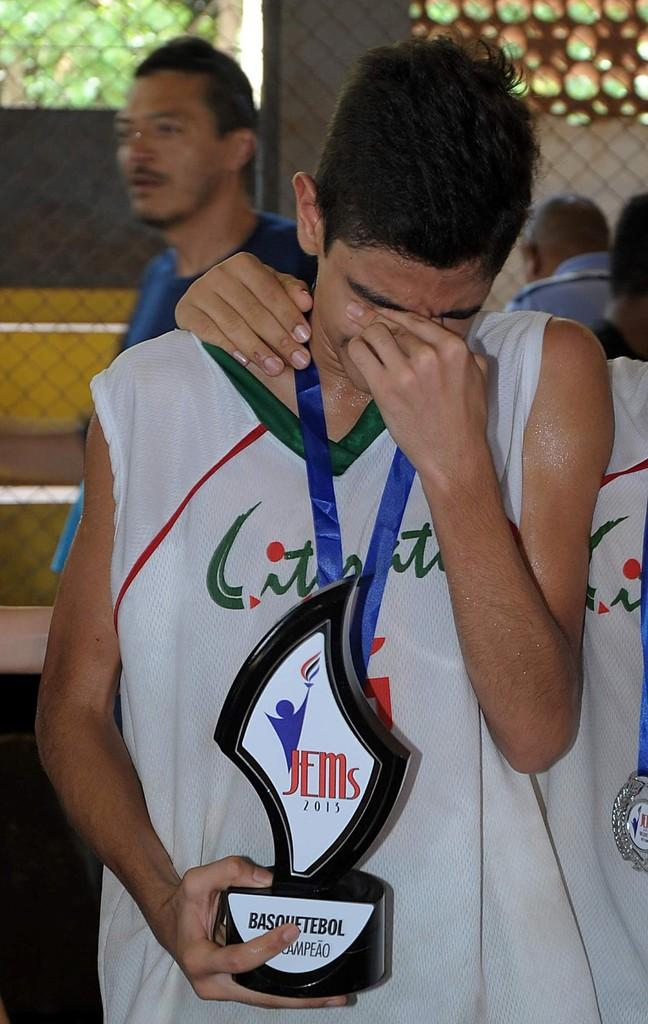<image>
Summarize the visual content of the image. A young man holding a trophy with the word JEMs on it. 